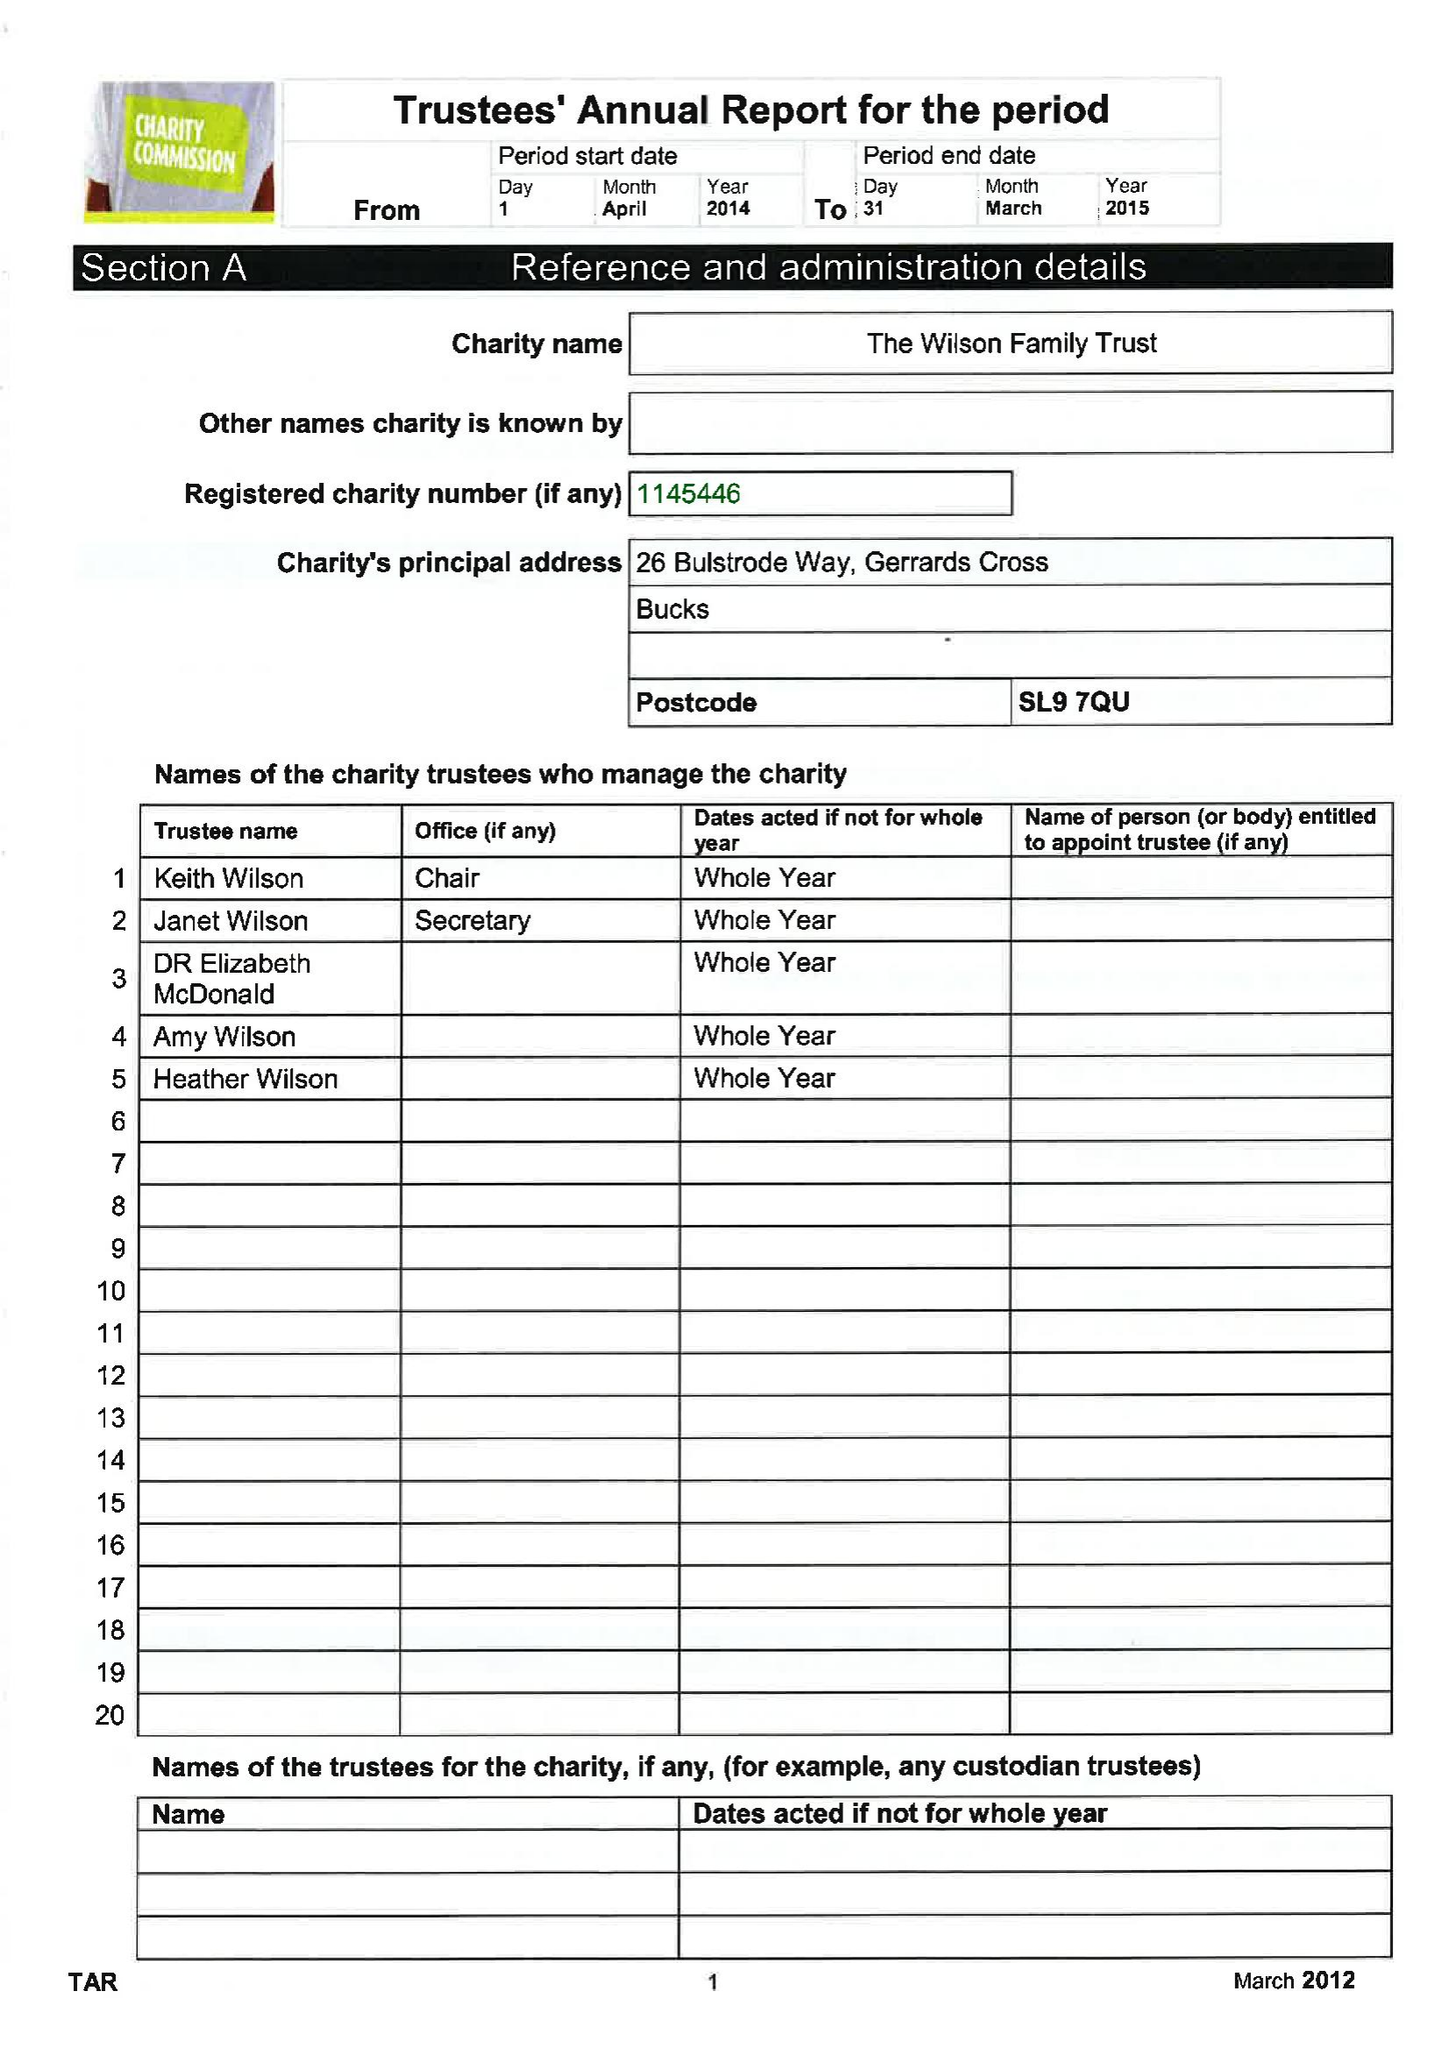What is the value for the report_date?
Answer the question using a single word or phrase. 2015-04-05 